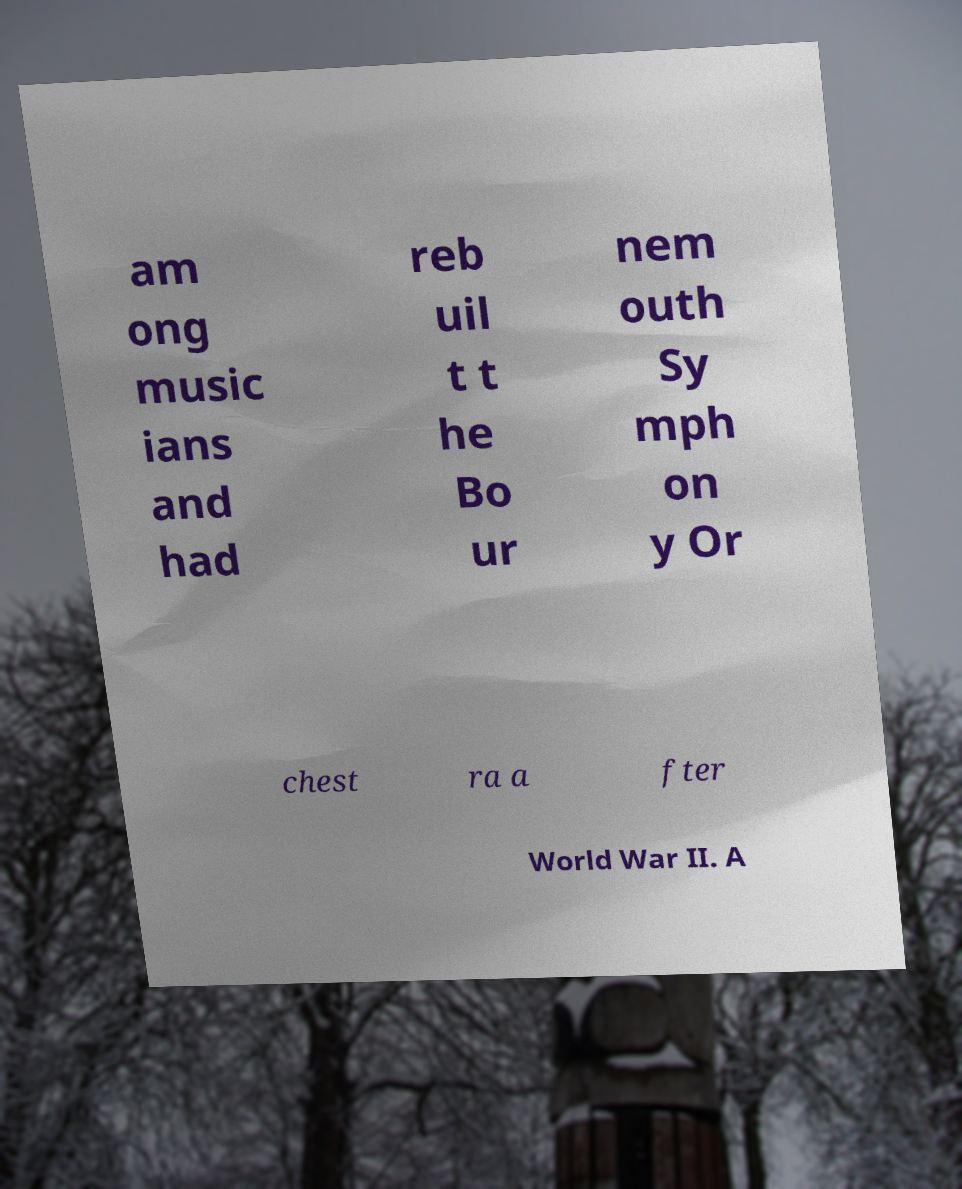What messages or text are displayed in this image? I need them in a readable, typed format. am ong music ians and had reb uil t t he Bo ur nem outh Sy mph on y Or chest ra a fter World War II. A 